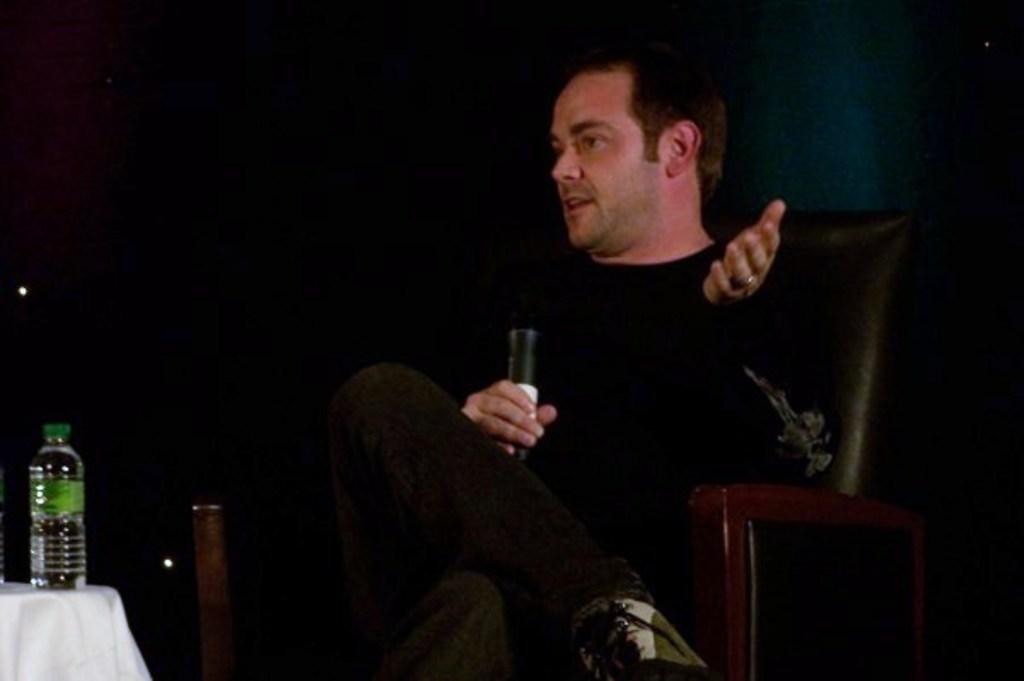Please provide a concise description of this image. This man wore black t-shirt and sitting on a chair. This man is holding a mic. In-front of this man there is a table, on table there is a cloth and bottle. 